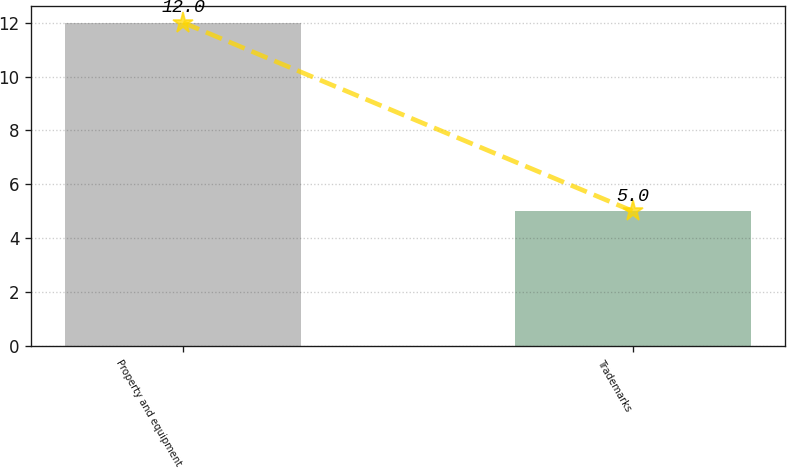<chart> <loc_0><loc_0><loc_500><loc_500><bar_chart><fcel>Property and equipment<fcel>Trademarks<nl><fcel>12<fcel>5<nl></chart> 